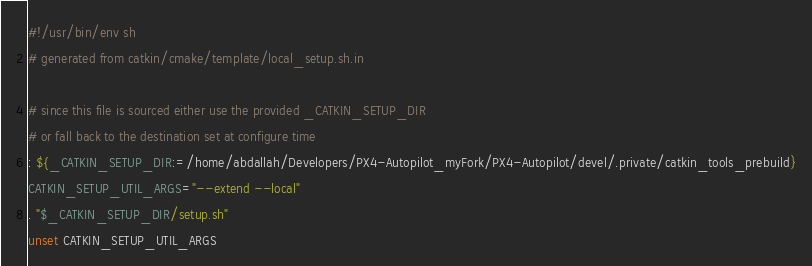<code> <loc_0><loc_0><loc_500><loc_500><_Bash_>#!/usr/bin/env sh
# generated from catkin/cmake/template/local_setup.sh.in

# since this file is sourced either use the provided _CATKIN_SETUP_DIR
# or fall back to the destination set at configure time
: ${_CATKIN_SETUP_DIR:=/home/abdallah/Developers/PX4-Autopilot_myFork/PX4-Autopilot/devel/.private/catkin_tools_prebuild}
CATKIN_SETUP_UTIL_ARGS="--extend --local"
. "$_CATKIN_SETUP_DIR/setup.sh"
unset CATKIN_SETUP_UTIL_ARGS
</code> 